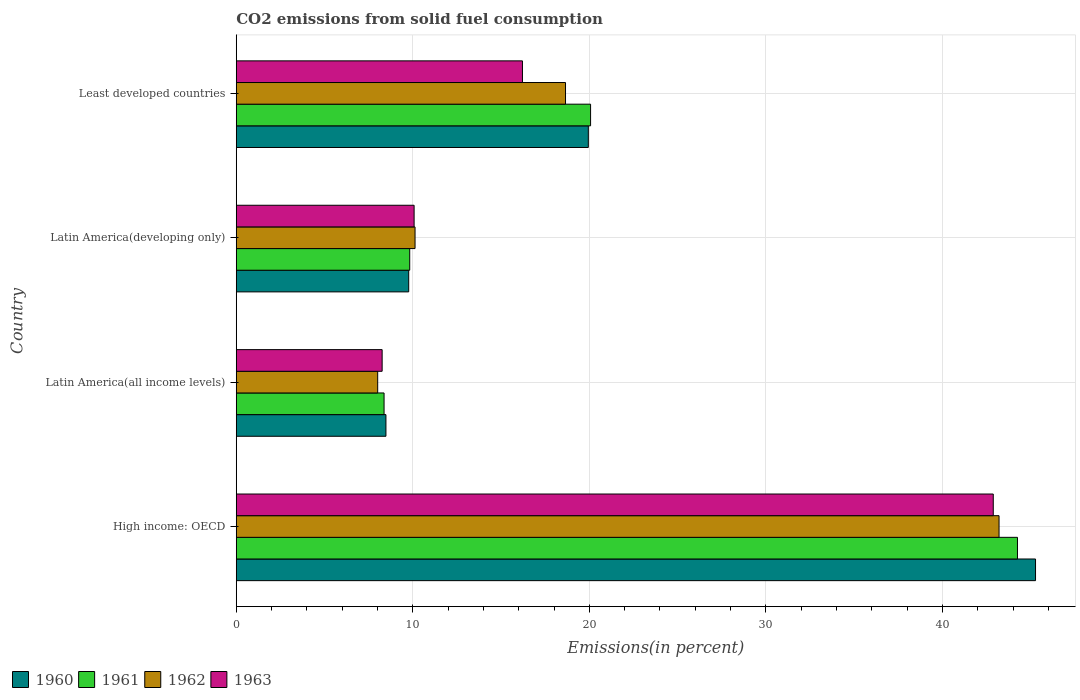How many groups of bars are there?
Make the answer very short. 4. Are the number of bars per tick equal to the number of legend labels?
Make the answer very short. Yes. What is the label of the 4th group of bars from the top?
Your answer should be very brief. High income: OECD. In how many cases, is the number of bars for a given country not equal to the number of legend labels?
Your answer should be very brief. 0. What is the total CO2 emitted in 1960 in Latin America(developing only)?
Your response must be concise. 9.77. Across all countries, what is the maximum total CO2 emitted in 1962?
Offer a very short reply. 43.2. Across all countries, what is the minimum total CO2 emitted in 1962?
Give a very brief answer. 8.01. In which country was the total CO2 emitted in 1961 maximum?
Make the answer very short. High income: OECD. In which country was the total CO2 emitted in 1961 minimum?
Your answer should be compact. Latin America(all income levels). What is the total total CO2 emitted in 1962 in the graph?
Your answer should be very brief. 79.99. What is the difference between the total CO2 emitted in 1963 in High income: OECD and that in Latin America(developing only)?
Your response must be concise. 32.8. What is the difference between the total CO2 emitted in 1961 in Latin America(all income levels) and the total CO2 emitted in 1960 in Least developed countries?
Your answer should be very brief. -11.57. What is the average total CO2 emitted in 1961 per country?
Your answer should be compact. 20.63. What is the difference between the total CO2 emitted in 1961 and total CO2 emitted in 1962 in High income: OECD?
Offer a terse response. 1.04. What is the ratio of the total CO2 emitted in 1960 in Latin America(all income levels) to that in Least developed countries?
Give a very brief answer. 0.43. What is the difference between the highest and the second highest total CO2 emitted in 1962?
Make the answer very short. 24.55. What is the difference between the highest and the lowest total CO2 emitted in 1960?
Give a very brief answer. 36.79. In how many countries, is the total CO2 emitted in 1963 greater than the average total CO2 emitted in 1963 taken over all countries?
Offer a terse response. 1. Is the sum of the total CO2 emitted in 1960 in High income: OECD and Latin America(all income levels) greater than the maximum total CO2 emitted in 1963 across all countries?
Offer a very short reply. Yes. What does the 4th bar from the bottom in High income: OECD represents?
Ensure brevity in your answer.  1963. Are all the bars in the graph horizontal?
Keep it short and to the point. Yes. Where does the legend appear in the graph?
Provide a succinct answer. Bottom left. What is the title of the graph?
Keep it short and to the point. CO2 emissions from solid fuel consumption. Does "2000" appear as one of the legend labels in the graph?
Provide a short and direct response. No. What is the label or title of the X-axis?
Offer a very short reply. Emissions(in percent). What is the label or title of the Y-axis?
Your response must be concise. Country. What is the Emissions(in percent) of 1960 in High income: OECD?
Provide a succinct answer. 45.27. What is the Emissions(in percent) in 1961 in High income: OECD?
Keep it short and to the point. 44.25. What is the Emissions(in percent) in 1962 in High income: OECD?
Your response must be concise. 43.2. What is the Emissions(in percent) of 1963 in High income: OECD?
Your response must be concise. 42.88. What is the Emissions(in percent) in 1960 in Latin America(all income levels)?
Offer a very short reply. 8.48. What is the Emissions(in percent) in 1961 in Latin America(all income levels)?
Give a very brief answer. 8.37. What is the Emissions(in percent) in 1962 in Latin America(all income levels)?
Provide a short and direct response. 8.01. What is the Emissions(in percent) of 1963 in Latin America(all income levels)?
Your answer should be compact. 8.26. What is the Emissions(in percent) in 1960 in Latin America(developing only)?
Give a very brief answer. 9.77. What is the Emissions(in percent) of 1961 in Latin America(developing only)?
Keep it short and to the point. 9.82. What is the Emissions(in percent) in 1962 in Latin America(developing only)?
Give a very brief answer. 10.13. What is the Emissions(in percent) of 1963 in Latin America(developing only)?
Provide a short and direct response. 10.07. What is the Emissions(in percent) in 1960 in Least developed countries?
Provide a short and direct response. 19.94. What is the Emissions(in percent) of 1961 in Least developed countries?
Give a very brief answer. 20.07. What is the Emissions(in percent) in 1962 in Least developed countries?
Make the answer very short. 18.65. What is the Emissions(in percent) of 1963 in Least developed countries?
Your answer should be compact. 16.21. Across all countries, what is the maximum Emissions(in percent) of 1960?
Make the answer very short. 45.27. Across all countries, what is the maximum Emissions(in percent) in 1961?
Offer a very short reply. 44.25. Across all countries, what is the maximum Emissions(in percent) of 1962?
Keep it short and to the point. 43.2. Across all countries, what is the maximum Emissions(in percent) of 1963?
Your answer should be compact. 42.88. Across all countries, what is the minimum Emissions(in percent) in 1960?
Keep it short and to the point. 8.48. Across all countries, what is the minimum Emissions(in percent) in 1961?
Offer a terse response. 8.37. Across all countries, what is the minimum Emissions(in percent) in 1962?
Provide a succinct answer. 8.01. Across all countries, what is the minimum Emissions(in percent) of 1963?
Provide a short and direct response. 8.26. What is the total Emissions(in percent) of 1960 in the graph?
Provide a short and direct response. 83.46. What is the total Emissions(in percent) of 1961 in the graph?
Provide a short and direct response. 82.51. What is the total Emissions(in percent) in 1962 in the graph?
Give a very brief answer. 79.99. What is the total Emissions(in percent) in 1963 in the graph?
Ensure brevity in your answer.  77.42. What is the difference between the Emissions(in percent) of 1960 in High income: OECD and that in Latin America(all income levels)?
Provide a short and direct response. 36.79. What is the difference between the Emissions(in percent) of 1961 in High income: OECD and that in Latin America(all income levels)?
Offer a very short reply. 35.88. What is the difference between the Emissions(in percent) of 1962 in High income: OECD and that in Latin America(all income levels)?
Offer a terse response. 35.19. What is the difference between the Emissions(in percent) of 1963 in High income: OECD and that in Latin America(all income levels)?
Your answer should be very brief. 34.61. What is the difference between the Emissions(in percent) of 1960 in High income: OECD and that in Latin America(developing only)?
Ensure brevity in your answer.  35.5. What is the difference between the Emissions(in percent) in 1961 in High income: OECD and that in Latin America(developing only)?
Your answer should be compact. 34.42. What is the difference between the Emissions(in percent) in 1962 in High income: OECD and that in Latin America(developing only)?
Provide a short and direct response. 33.08. What is the difference between the Emissions(in percent) of 1963 in High income: OECD and that in Latin America(developing only)?
Your answer should be compact. 32.8. What is the difference between the Emissions(in percent) of 1960 in High income: OECD and that in Least developed countries?
Make the answer very short. 25.33. What is the difference between the Emissions(in percent) in 1961 in High income: OECD and that in Least developed countries?
Your answer should be very brief. 24.18. What is the difference between the Emissions(in percent) of 1962 in High income: OECD and that in Least developed countries?
Provide a short and direct response. 24.55. What is the difference between the Emissions(in percent) of 1963 in High income: OECD and that in Least developed countries?
Ensure brevity in your answer.  26.67. What is the difference between the Emissions(in percent) in 1960 in Latin America(all income levels) and that in Latin America(developing only)?
Ensure brevity in your answer.  -1.29. What is the difference between the Emissions(in percent) of 1961 in Latin America(all income levels) and that in Latin America(developing only)?
Ensure brevity in your answer.  -1.45. What is the difference between the Emissions(in percent) in 1962 in Latin America(all income levels) and that in Latin America(developing only)?
Make the answer very short. -2.12. What is the difference between the Emissions(in percent) in 1963 in Latin America(all income levels) and that in Latin America(developing only)?
Your response must be concise. -1.81. What is the difference between the Emissions(in percent) of 1960 in Latin America(all income levels) and that in Least developed countries?
Make the answer very short. -11.46. What is the difference between the Emissions(in percent) of 1961 in Latin America(all income levels) and that in Least developed countries?
Provide a succinct answer. -11.7. What is the difference between the Emissions(in percent) of 1962 in Latin America(all income levels) and that in Least developed countries?
Provide a short and direct response. -10.64. What is the difference between the Emissions(in percent) in 1963 in Latin America(all income levels) and that in Least developed countries?
Provide a succinct answer. -7.95. What is the difference between the Emissions(in percent) in 1960 in Latin America(developing only) and that in Least developed countries?
Provide a succinct answer. -10.17. What is the difference between the Emissions(in percent) in 1961 in Latin America(developing only) and that in Least developed countries?
Your response must be concise. -10.24. What is the difference between the Emissions(in percent) in 1962 in Latin America(developing only) and that in Least developed countries?
Give a very brief answer. -8.52. What is the difference between the Emissions(in percent) in 1963 in Latin America(developing only) and that in Least developed countries?
Keep it short and to the point. -6.14. What is the difference between the Emissions(in percent) of 1960 in High income: OECD and the Emissions(in percent) of 1961 in Latin America(all income levels)?
Your answer should be compact. 36.9. What is the difference between the Emissions(in percent) of 1960 in High income: OECD and the Emissions(in percent) of 1962 in Latin America(all income levels)?
Offer a very short reply. 37.26. What is the difference between the Emissions(in percent) of 1960 in High income: OECD and the Emissions(in percent) of 1963 in Latin America(all income levels)?
Offer a terse response. 37.01. What is the difference between the Emissions(in percent) in 1961 in High income: OECD and the Emissions(in percent) in 1962 in Latin America(all income levels)?
Ensure brevity in your answer.  36.24. What is the difference between the Emissions(in percent) of 1961 in High income: OECD and the Emissions(in percent) of 1963 in Latin America(all income levels)?
Give a very brief answer. 35.99. What is the difference between the Emissions(in percent) in 1962 in High income: OECD and the Emissions(in percent) in 1963 in Latin America(all income levels)?
Your answer should be very brief. 34.94. What is the difference between the Emissions(in percent) in 1960 in High income: OECD and the Emissions(in percent) in 1961 in Latin America(developing only)?
Offer a terse response. 35.45. What is the difference between the Emissions(in percent) in 1960 in High income: OECD and the Emissions(in percent) in 1962 in Latin America(developing only)?
Give a very brief answer. 35.14. What is the difference between the Emissions(in percent) of 1960 in High income: OECD and the Emissions(in percent) of 1963 in Latin America(developing only)?
Keep it short and to the point. 35.2. What is the difference between the Emissions(in percent) in 1961 in High income: OECD and the Emissions(in percent) in 1962 in Latin America(developing only)?
Make the answer very short. 34.12. What is the difference between the Emissions(in percent) in 1961 in High income: OECD and the Emissions(in percent) in 1963 in Latin America(developing only)?
Make the answer very short. 34.17. What is the difference between the Emissions(in percent) of 1962 in High income: OECD and the Emissions(in percent) of 1963 in Latin America(developing only)?
Make the answer very short. 33.13. What is the difference between the Emissions(in percent) of 1960 in High income: OECD and the Emissions(in percent) of 1961 in Least developed countries?
Provide a succinct answer. 25.2. What is the difference between the Emissions(in percent) of 1960 in High income: OECD and the Emissions(in percent) of 1962 in Least developed countries?
Make the answer very short. 26.62. What is the difference between the Emissions(in percent) of 1960 in High income: OECD and the Emissions(in percent) of 1963 in Least developed countries?
Make the answer very short. 29.06. What is the difference between the Emissions(in percent) of 1961 in High income: OECD and the Emissions(in percent) of 1962 in Least developed countries?
Give a very brief answer. 25.6. What is the difference between the Emissions(in percent) of 1961 in High income: OECD and the Emissions(in percent) of 1963 in Least developed countries?
Your response must be concise. 28.04. What is the difference between the Emissions(in percent) in 1962 in High income: OECD and the Emissions(in percent) in 1963 in Least developed countries?
Make the answer very short. 26.99. What is the difference between the Emissions(in percent) in 1960 in Latin America(all income levels) and the Emissions(in percent) in 1961 in Latin America(developing only)?
Ensure brevity in your answer.  -1.35. What is the difference between the Emissions(in percent) in 1960 in Latin America(all income levels) and the Emissions(in percent) in 1962 in Latin America(developing only)?
Make the answer very short. -1.65. What is the difference between the Emissions(in percent) in 1960 in Latin America(all income levels) and the Emissions(in percent) in 1963 in Latin America(developing only)?
Keep it short and to the point. -1.6. What is the difference between the Emissions(in percent) of 1961 in Latin America(all income levels) and the Emissions(in percent) of 1962 in Latin America(developing only)?
Provide a short and direct response. -1.75. What is the difference between the Emissions(in percent) in 1961 in Latin America(all income levels) and the Emissions(in percent) in 1963 in Latin America(developing only)?
Make the answer very short. -1.7. What is the difference between the Emissions(in percent) in 1962 in Latin America(all income levels) and the Emissions(in percent) in 1963 in Latin America(developing only)?
Offer a terse response. -2.06. What is the difference between the Emissions(in percent) in 1960 in Latin America(all income levels) and the Emissions(in percent) in 1961 in Least developed countries?
Ensure brevity in your answer.  -11.59. What is the difference between the Emissions(in percent) of 1960 in Latin America(all income levels) and the Emissions(in percent) of 1962 in Least developed countries?
Keep it short and to the point. -10.17. What is the difference between the Emissions(in percent) of 1960 in Latin America(all income levels) and the Emissions(in percent) of 1963 in Least developed countries?
Your answer should be very brief. -7.73. What is the difference between the Emissions(in percent) of 1961 in Latin America(all income levels) and the Emissions(in percent) of 1962 in Least developed countries?
Offer a very short reply. -10.28. What is the difference between the Emissions(in percent) of 1961 in Latin America(all income levels) and the Emissions(in percent) of 1963 in Least developed countries?
Offer a very short reply. -7.84. What is the difference between the Emissions(in percent) of 1962 in Latin America(all income levels) and the Emissions(in percent) of 1963 in Least developed countries?
Keep it short and to the point. -8.2. What is the difference between the Emissions(in percent) of 1960 in Latin America(developing only) and the Emissions(in percent) of 1961 in Least developed countries?
Ensure brevity in your answer.  -10.3. What is the difference between the Emissions(in percent) in 1960 in Latin America(developing only) and the Emissions(in percent) in 1962 in Least developed countries?
Provide a short and direct response. -8.88. What is the difference between the Emissions(in percent) in 1960 in Latin America(developing only) and the Emissions(in percent) in 1963 in Least developed countries?
Ensure brevity in your answer.  -6.44. What is the difference between the Emissions(in percent) in 1961 in Latin America(developing only) and the Emissions(in percent) in 1962 in Least developed countries?
Your answer should be very brief. -8.82. What is the difference between the Emissions(in percent) of 1961 in Latin America(developing only) and the Emissions(in percent) of 1963 in Least developed countries?
Provide a short and direct response. -6.39. What is the difference between the Emissions(in percent) of 1962 in Latin America(developing only) and the Emissions(in percent) of 1963 in Least developed countries?
Your answer should be compact. -6.08. What is the average Emissions(in percent) of 1960 per country?
Provide a succinct answer. 20.86. What is the average Emissions(in percent) in 1961 per country?
Make the answer very short. 20.63. What is the average Emissions(in percent) of 1962 per country?
Your response must be concise. 20. What is the average Emissions(in percent) in 1963 per country?
Your answer should be very brief. 19.36. What is the difference between the Emissions(in percent) in 1960 and Emissions(in percent) in 1961 in High income: OECD?
Keep it short and to the point. 1.02. What is the difference between the Emissions(in percent) of 1960 and Emissions(in percent) of 1962 in High income: OECD?
Offer a terse response. 2.07. What is the difference between the Emissions(in percent) of 1960 and Emissions(in percent) of 1963 in High income: OECD?
Give a very brief answer. 2.39. What is the difference between the Emissions(in percent) in 1961 and Emissions(in percent) in 1962 in High income: OECD?
Your answer should be compact. 1.04. What is the difference between the Emissions(in percent) in 1961 and Emissions(in percent) in 1963 in High income: OECD?
Offer a terse response. 1.37. What is the difference between the Emissions(in percent) in 1962 and Emissions(in percent) in 1963 in High income: OECD?
Offer a terse response. 0.33. What is the difference between the Emissions(in percent) in 1960 and Emissions(in percent) in 1961 in Latin America(all income levels)?
Your response must be concise. 0.11. What is the difference between the Emissions(in percent) in 1960 and Emissions(in percent) in 1962 in Latin America(all income levels)?
Provide a succinct answer. 0.47. What is the difference between the Emissions(in percent) of 1960 and Emissions(in percent) of 1963 in Latin America(all income levels)?
Keep it short and to the point. 0.22. What is the difference between the Emissions(in percent) of 1961 and Emissions(in percent) of 1962 in Latin America(all income levels)?
Ensure brevity in your answer.  0.36. What is the difference between the Emissions(in percent) in 1961 and Emissions(in percent) in 1963 in Latin America(all income levels)?
Make the answer very short. 0.11. What is the difference between the Emissions(in percent) in 1962 and Emissions(in percent) in 1963 in Latin America(all income levels)?
Make the answer very short. -0.25. What is the difference between the Emissions(in percent) of 1960 and Emissions(in percent) of 1961 in Latin America(developing only)?
Your answer should be compact. -0.06. What is the difference between the Emissions(in percent) in 1960 and Emissions(in percent) in 1962 in Latin America(developing only)?
Provide a short and direct response. -0.36. What is the difference between the Emissions(in percent) of 1960 and Emissions(in percent) of 1963 in Latin America(developing only)?
Your answer should be very brief. -0.31. What is the difference between the Emissions(in percent) of 1961 and Emissions(in percent) of 1962 in Latin America(developing only)?
Ensure brevity in your answer.  -0.3. What is the difference between the Emissions(in percent) in 1961 and Emissions(in percent) in 1963 in Latin America(developing only)?
Give a very brief answer. -0.25. What is the difference between the Emissions(in percent) in 1962 and Emissions(in percent) in 1963 in Latin America(developing only)?
Offer a terse response. 0.05. What is the difference between the Emissions(in percent) of 1960 and Emissions(in percent) of 1961 in Least developed countries?
Provide a short and direct response. -0.13. What is the difference between the Emissions(in percent) of 1960 and Emissions(in percent) of 1962 in Least developed countries?
Provide a succinct answer. 1.29. What is the difference between the Emissions(in percent) of 1960 and Emissions(in percent) of 1963 in Least developed countries?
Make the answer very short. 3.73. What is the difference between the Emissions(in percent) of 1961 and Emissions(in percent) of 1962 in Least developed countries?
Offer a terse response. 1.42. What is the difference between the Emissions(in percent) in 1961 and Emissions(in percent) in 1963 in Least developed countries?
Provide a short and direct response. 3.86. What is the difference between the Emissions(in percent) in 1962 and Emissions(in percent) in 1963 in Least developed countries?
Provide a succinct answer. 2.44. What is the ratio of the Emissions(in percent) of 1960 in High income: OECD to that in Latin America(all income levels)?
Give a very brief answer. 5.34. What is the ratio of the Emissions(in percent) of 1961 in High income: OECD to that in Latin America(all income levels)?
Offer a terse response. 5.29. What is the ratio of the Emissions(in percent) in 1962 in High income: OECD to that in Latin America(all income levels)?
Ensure brevity in your answer.  5.39. What is the ratio of the Emissions(in percent) of 1963 in High income: OECD to that in Latin America(all income levels)?
Keep it short and to the point. 5.19. What is the ratio of the Emissions(in percent) of 1960 in High income: OECD to that in Latin America(developing only)?
Offer a terse response. 4.63. What is the ratio of the Emissions(in percent) of 1961 in High income: OECD to that in Latin America(developing only)?
Your answer should be very brief. 4.5. What is the ratio of the Emissions(in percent) in 1962 in High income: OECD to that in Latin America(developing only)?
Provide a short and direct response. 4.27. What is the ratio of the Emissions(in percent) in 1963 in High income: OECD to that in Latin America(developing only)?
Make the answer very short. 4.26. What is the ratio of the Emissions(in percent) in 1960 in High income: OECD to that in Least developed countries?
Offer a very short reply. 2.27. What is the ratio of the Emissions(in percent) in 1961 in High income: OECD to that in Least developed countries?
Offer a very short reply. 2.2. What is the ratio of the Emissions(in percent) of 1962 in High income: OECD to that in Least developed countries?
Offer a terse response. 2.32. What is the ratio of the Emissions(in percent) in 1963 in High income: OECD to that in Least developed countries?
Offer a terse response. 2.65. What is the ratio of the Emissions(in percent) of 1960 in Latin America(all income levels) to that in Latin America(developing only)?
Your answer should be very brief. 0.87. What is the ratio of the Emissions(in percent) in 1961 in Latin America(all income levels) to that in Latin America(developing only)?
Give a very brief answer. 0.85. What is the ratio of the Emissions(in percent) in 1962 in Latin America(all income levels) to that in Latin America(developing only)?
Keep it short and to the point. 0.79. What is the ratio of the Emissions(in percent) of 1963 in Latin America(all income levels) to that in Latin America(developing only)?
Provide a succinct answer. 0.82. What is the ratio of the Emissions(in percent) in 1960 in Latin America(all income levels) to that in Least developed countries?
Your answer should be very brief. 0.43. What is the ratio of the Emissions(in percent) of 1961 in Latin America(all income levels) to that in Least developed countries?
Provide a succinct answer. 0.42. What is the ratio of the Emissions(in percent) in 1962 in Latin America(all income levels) to that in Least developed countries?
Your answer should be compact. 0.43. What is the ratio of the Emissions(in percent) of 1963 in Latin America(all income levels) to that in Least developed countries?
Provide a short and direct response. 0.51. What is the ratio of the Emissions(in percent) in 1960 in Latin America(developing only) to that in Least developed countries?
Provide a succinct answer. 0.49. What is the ratio of the Emissions(in percent) of 1961 in Latin America(developing only) to that in Least developed countries?
Provide a succinct answer. 0.49. What is the ratio of the Emissions(in percent) in 1962 in Latin America(developing only) to that in Least developed countries?
Keep it short and to the point. 0.54. What is the ratio of the Emissions(in percent) of 1963 in Latin America(developing only) to that in Least developed countries?
Provide a succinct answer. 0.62. What is the difference between the highest and the second highest Emissions(in percent) in 1960?
Offer a very short reply. 25.33. What is the difference between the highest and the second highest Emissions(in percent) of 1961?
Give a very brief answer. 24.18. What is the difference between the highest and the second highest Emissions(in percent) in 1962?
Keep it short and to the point. 24.55. What is the difference between the highest and the second highest Emissions(in percent) in 1963?
Provide a short and direct response. 26.67. What is the difference between the highest and the lowest Emissions(in percent) in 1960?
Make the answer very short. 36.79. What is the difference between the highest and the lowest Emissions(in percent) in 1961?
Ensure brevity in your answer.  35.88. What is the difference between the highest and the lowest Emissions(in percent) of 1962?
Ensure brevity in your answer.  35.19. What is the difference between the highest and the lowest Emissions(in percent) of 1963?
Your answer should be compact. 34.61. 